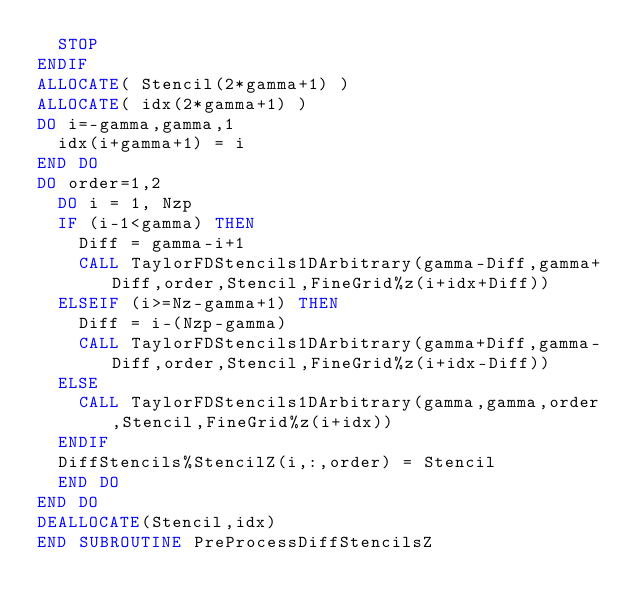Convert code to text. <code><loc_0><loc_0><loc_500><loc_500><_FORTRAN_>	STOP
ENDIF
ALLOCATE( Stencil(2*gamma+1) )
ALLOCATE( idx(2*gamma+1) )
DO i=-gamma,gamma,1
	idx(i+gamma+1) = i
END DO
DO order=1,2
  DO i = 1, Nzp
	IF (i-1<gamma) THEN
		Diff = gamma-i+1
		CALL TaylorFDStencils1DArbitrary(gamma-Diff,gamma+Diff,order,Stencil,FineGrid%z(i+idx+Diff))
	ELSEIF (i>=Nz-gamma+1) THEN
		Diff = i-(Nzp-gamma)
		CALL TaylorFDStencils1DArbitrary(gamma+Diff,gamma-Diff,order,Stencil,FineGrid%z(i+idx-Diff))
	ELSE
		CALL TaylorFDStencils1DArbitrary(gamma,gamma,order,Stencil,FineGrid%z(i+idx))
	ENDIF
	DiffStencils%StencilZ(i,:,order) = Stencil
  END DO
END DO
DEALLOCATE(Stencil,idx)
END SUBROUTINE PreProcessDiffStencilsZ
</code> 